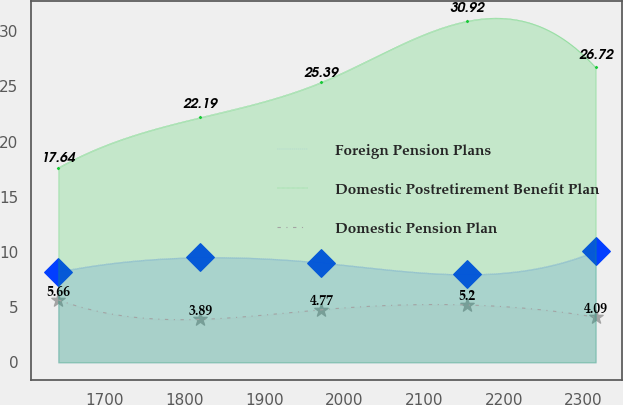Convert chart to OTSL. <chart><loc_0><loc_0><loc_500><loc_500><line_chart><ecel><fcel>Foreign Pension Plans<fcel>Domestic Postretirement Benefit Plan<fcel>Domestic Pension Plan<nl><fcel>1642.18<fcel>8.21<fcel>17.64<fcel>5.66<nl><fcel>1820.13<fcel>9.51<fcel>22.19<fcel>3.89<nl><fcel>1971.65<fcel>9.03<fcel>25.39<fcel>4.77<nl><fcel>2154.02<fcel>7.97<fcel>30.92<fcel>5.2<nl><fcel>2315.12<fcel>10.09<fcel>26.72<fcel>4.09<nl></chart> 